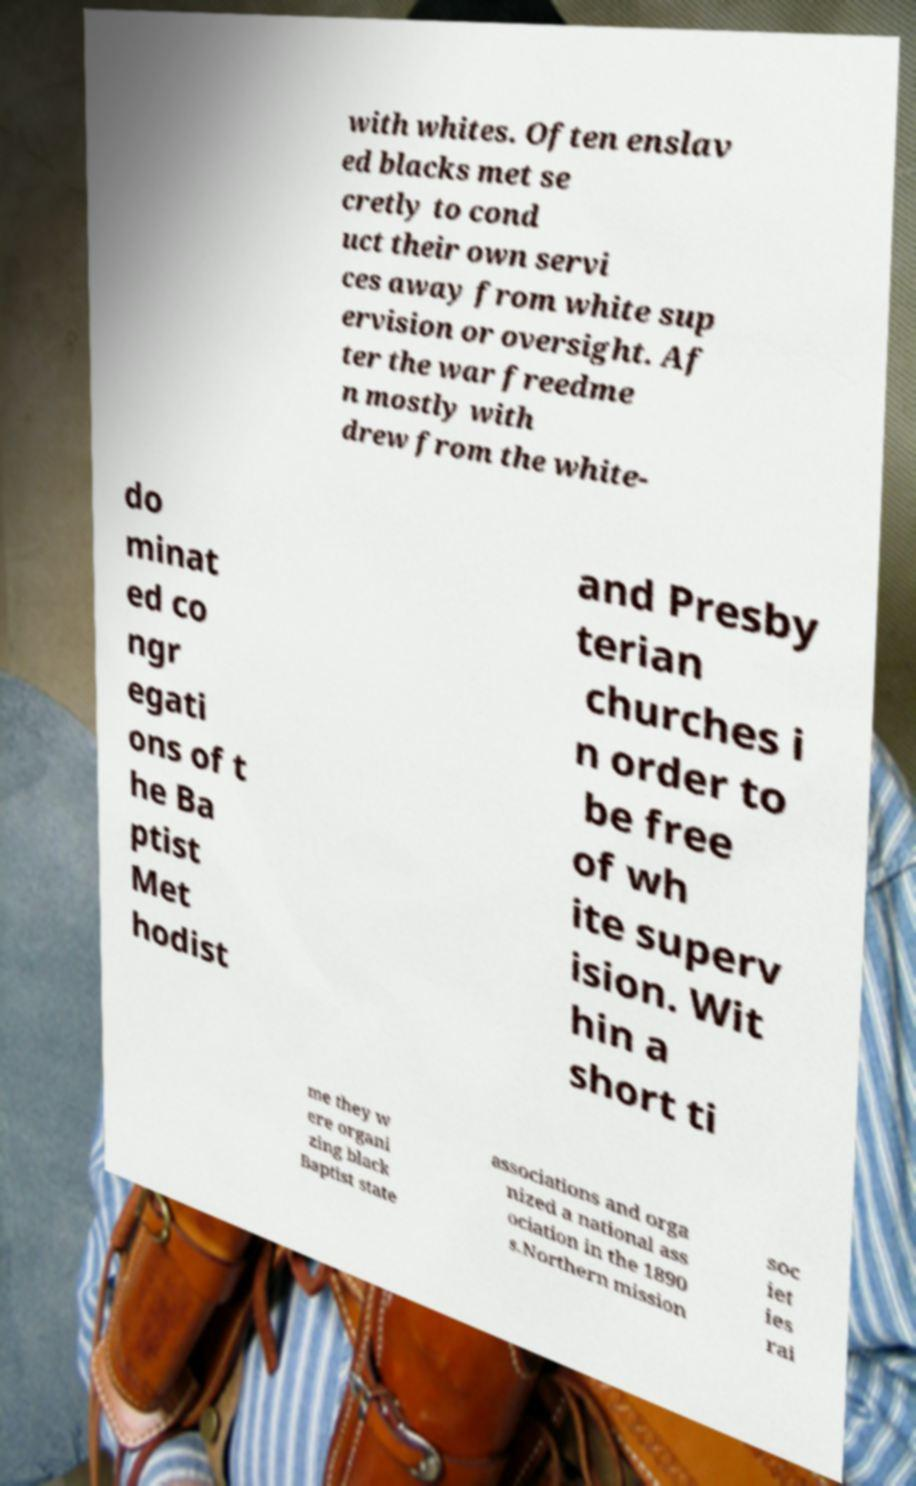Could you extract and type out the text from this image? with whites. Often enslav ed blacks met se cretly to cond uct their own servi ces away from white sup ervision or oversight. Af ter the war freedme n mostly with drew from the white- do minat ed co ngr egati ons of t he Ba ptist Met hodist and Presby terian churches i n order to be free of wh ite superv ision. Wit hin a short ti me they w ere organi zing black Baptist state associations and orga nized a national ass ociation in the 1890 s.Northern mission soc iet ies rai 